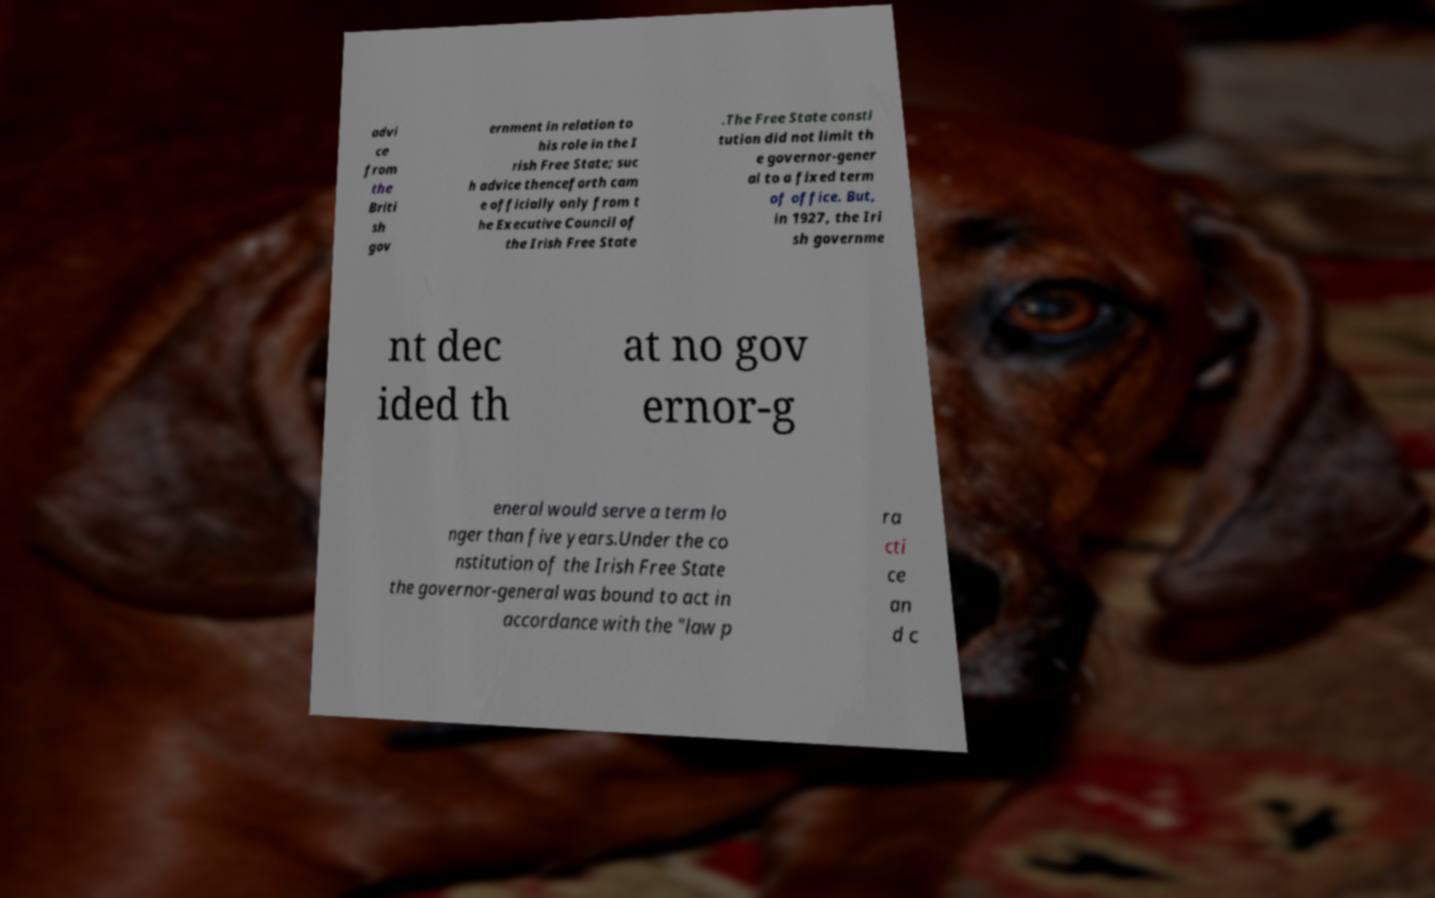There's text embedded in this image that I need extracted. Can you transcribe it verbatim? advi ce from the Briti sh gov ernment in relation to his role in the I rish Free State; suc h advice thenceforth cam e officially only from t he Executive Council of the Irish Free State .The Free State consti tution did not limit th e governor-gener al to a fixed term of office. But, in 1927, the Iri sh governme nt dec ided th at no gov ernor-g eneral would serve a term lo nger than five years.Under the co nstitution of the Irish Free State the governor-general was bound to act in accordance with the "law p ra cti ce an d c 